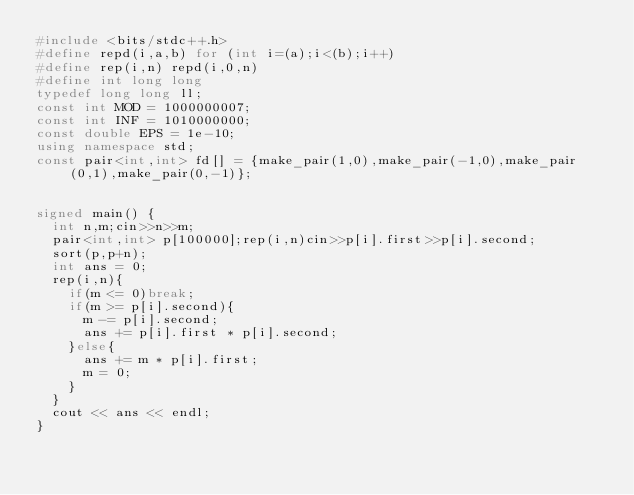Convert code to text. <code><loc_0><loc_0><loc_500><loc_500><_C++_>#include <bits/stdc++.h>
#define repd(i,a,b) for (int i=(a);i<(b);i++)
#define rep(i,n) repd(i,0,n)
#define int long long
typedef long long ll;
const int MOD = 1000000007;
const int INF = 1010000000;
const double EPS = 1e-10;
using namespace std;
const pair<int,int> fd[] = {make_pair(1,0),make_pair(-1,0),make_pair(0,1),make_pair(0,-1)}; 


signed main() {
  int n,m;cin>>n>>m;
  pair<int,int> p[100000];rep(i,n)cin>>p[i].first>>p[i].second;
  sort(p,p+n);
  int ans = 0;
  rep(i,n){
    if(m <= 0)break;
    if(m >= p[i].second){
      m -= p[i].second;
      ans += p[i].first * p[i].second;
    }else{
      ans += m * p[i].first;
      m = 0;
    }
  }
  cout << ans << endl;
}
</code> 